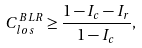<formula> <loc_0><loc_0><loc_500><loc_500>C _ { l o s } ^ { B L R } \geq \frac { 1 - I _ { c } - I _ { r } } { 1 - I _ { c } } ,</formula> 